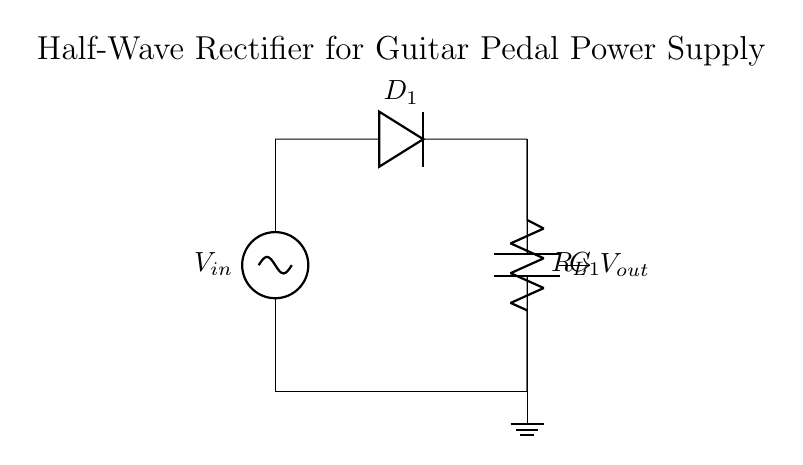What is the function of the diode in this circuit? The diode allows current to flow in one direction only, effectively blocking the negative part of the input AC signal and allowing only the positive half, which is essential for rectification.
Answer: rectification What is the component labeled as R_L? R_L represents the load resistor in the circuit, which the rectified output voltage supplies. It simulates the load that the power supply will drive in the guitar pedal.
Answer: load resistor What type of rectifier is represented in this circuit? The circuit is identified as a half-wave rectifier because it only allows one half of the AC input waveform to pass, blocking the other half.
Answer: half-wave What is the output voltage's nature in this configuration? The output voltage will be pulsating DC, as it consists of only the positive half of the AC waveform, which does not provide a steady voltage level.
Answer: pulsating DC How does the smoothing capacitor function in this circuit? The capacitor C_1 smooths the pulsating output from the rectified voltage by charging during the peaks of the waveform and discharging during the troughs, helping to reduce voltage fluctuations.
Answer: smoothing 